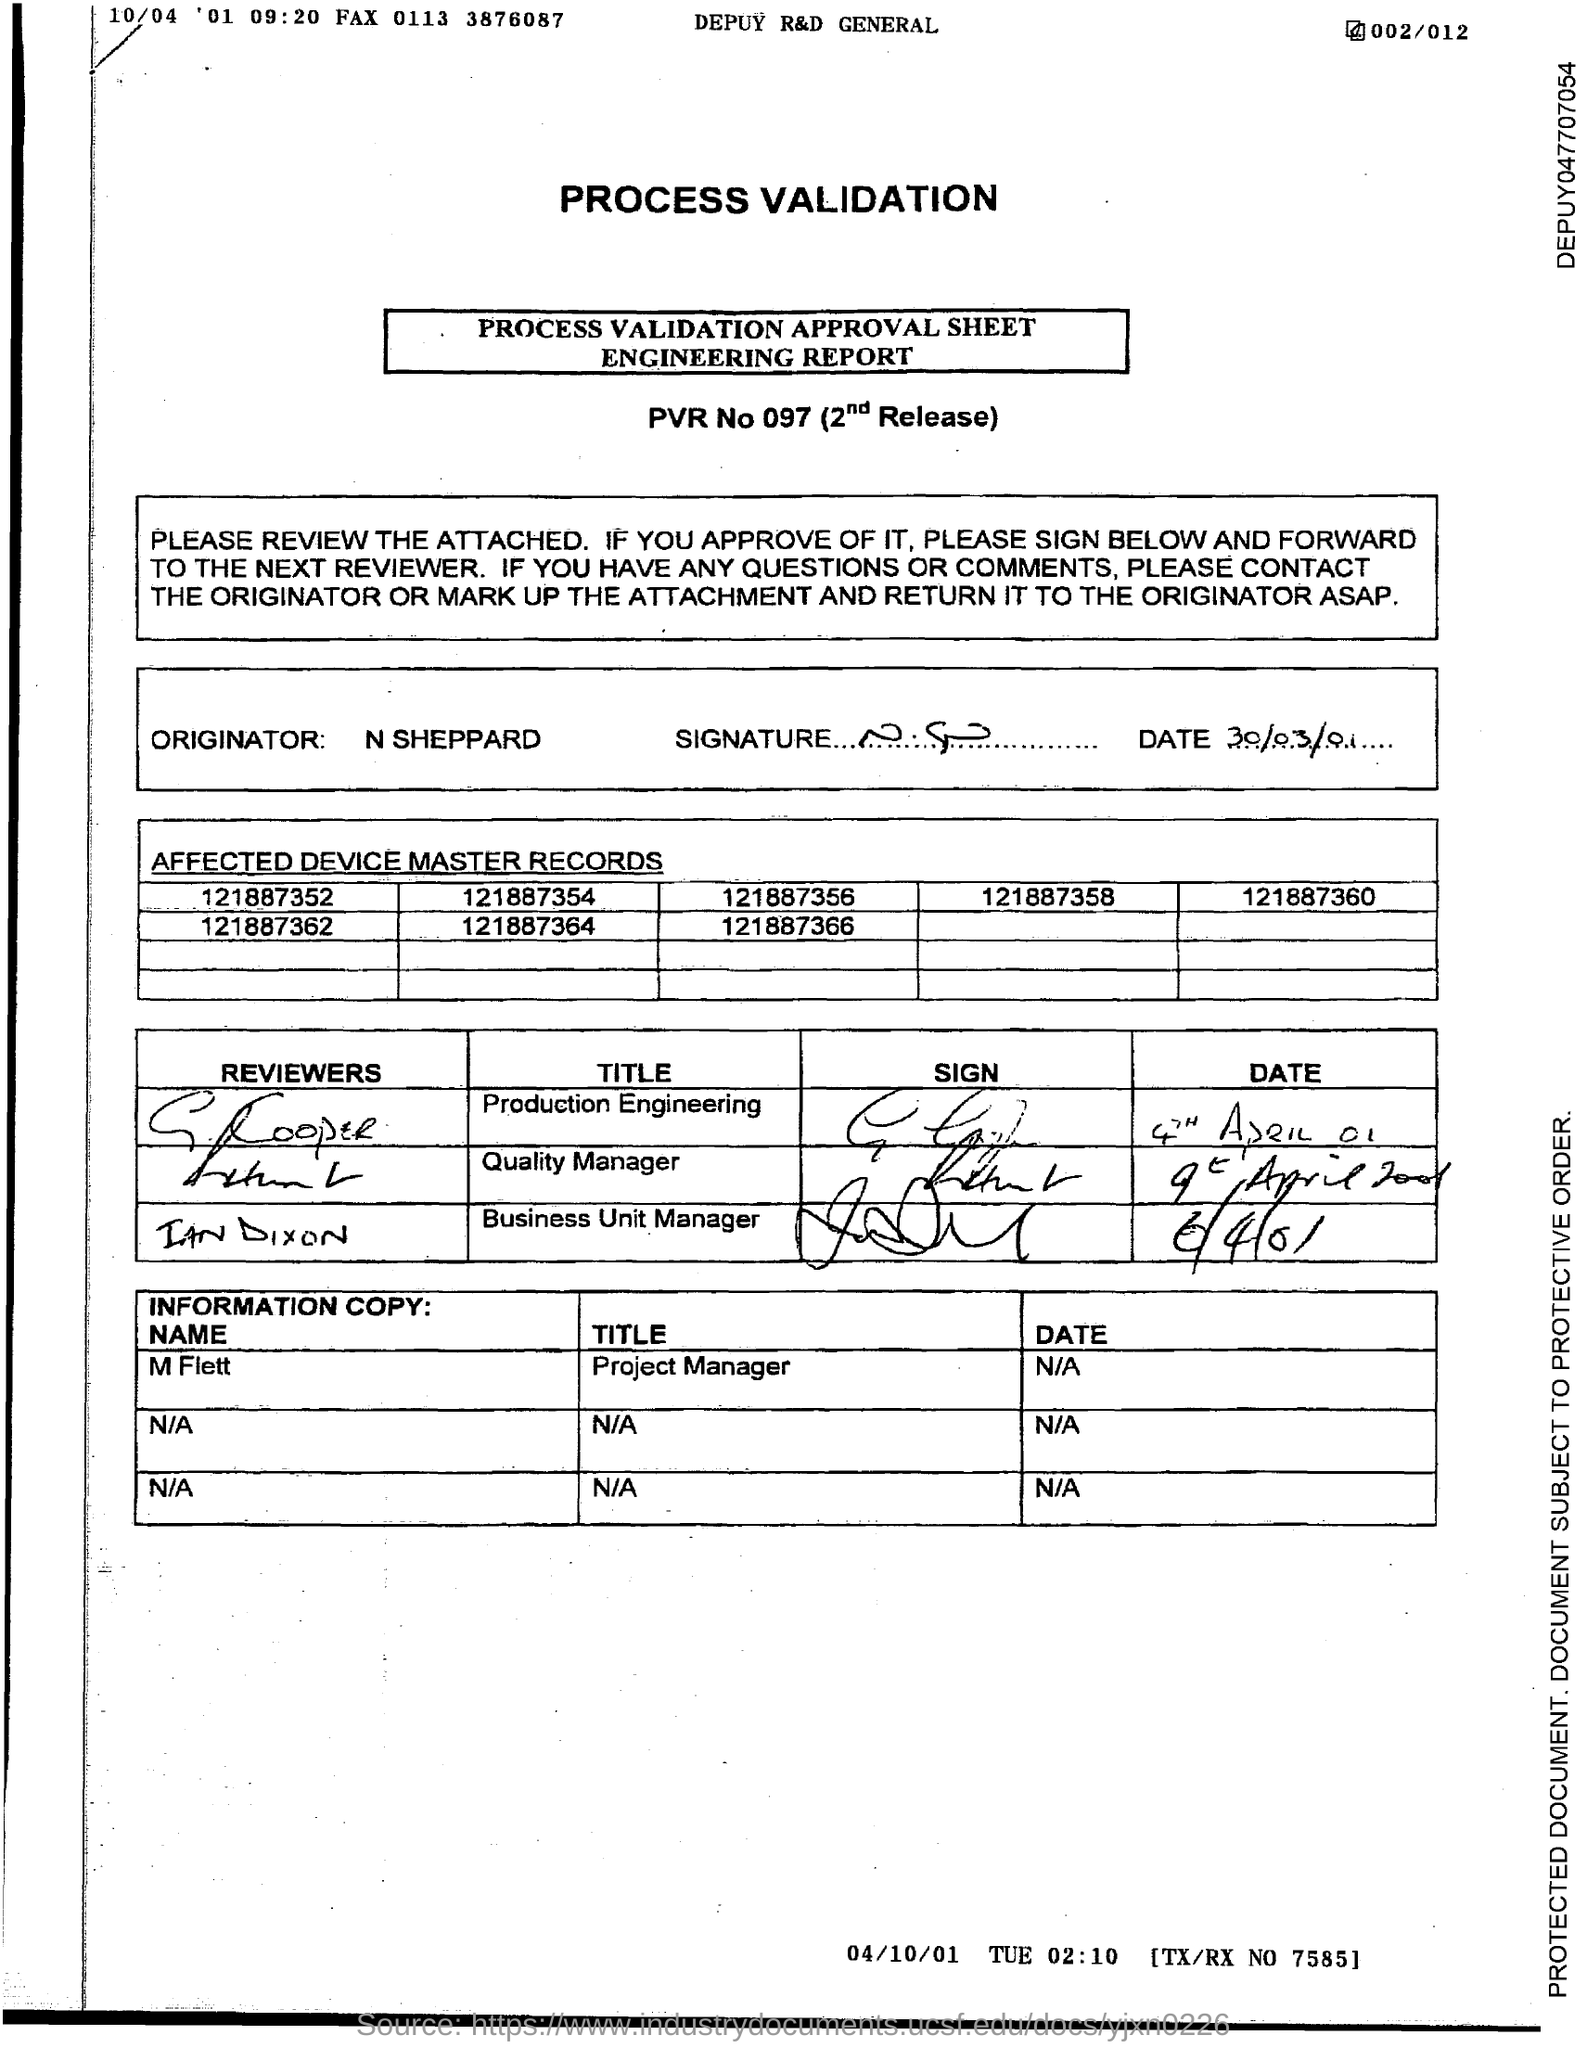Give some essential details in this illustration. On March 30th, 2001, N Sheppard signed the date as "30/03/01. The originator listed on the process validation approval sheet is N Sheppard. 